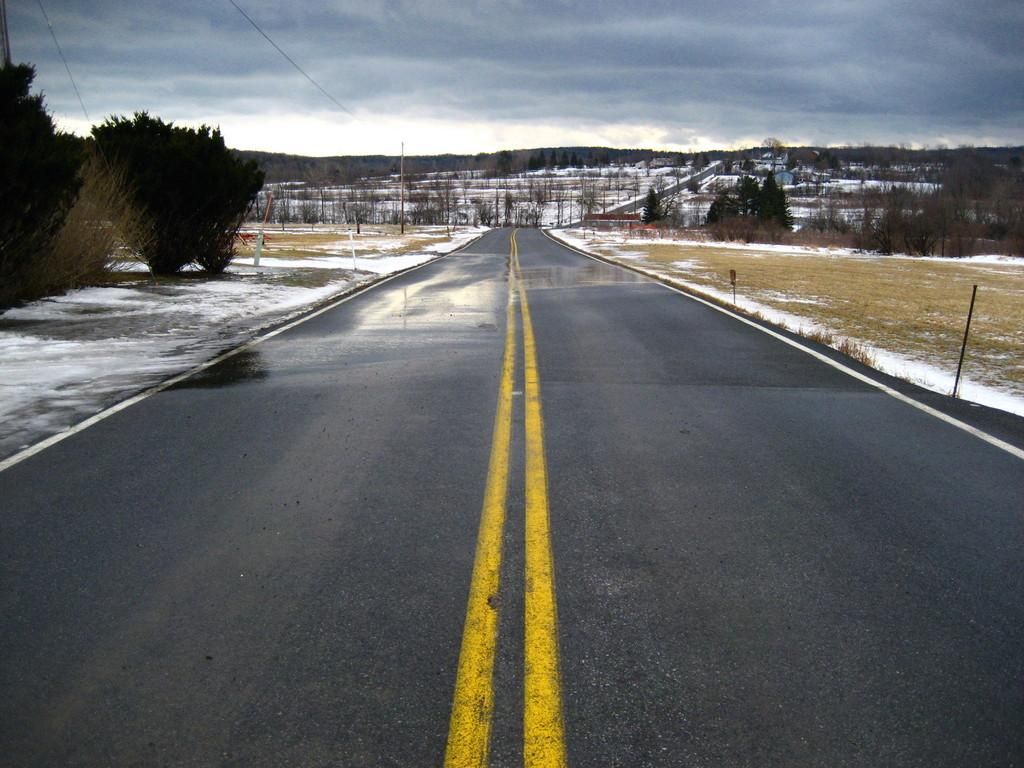What is in the foreground of the image? There is a road in the foreground of the image. What is the condition of the ground on either side of the road? There is snow on either side of the road. What type of landscape is present on either side of the road? Land is present on either side of the road. What type of vegetation can be seen on either side of the road? Trees are visible on either side of the road. What can be seen in the background of the image? Trees, snow, mountains, and the sky are visible in the background of the image. What type of meat is being served at the picnic in the image? There is no picnic or meat present in the image; it features a snowy landscape with a road and trees. 